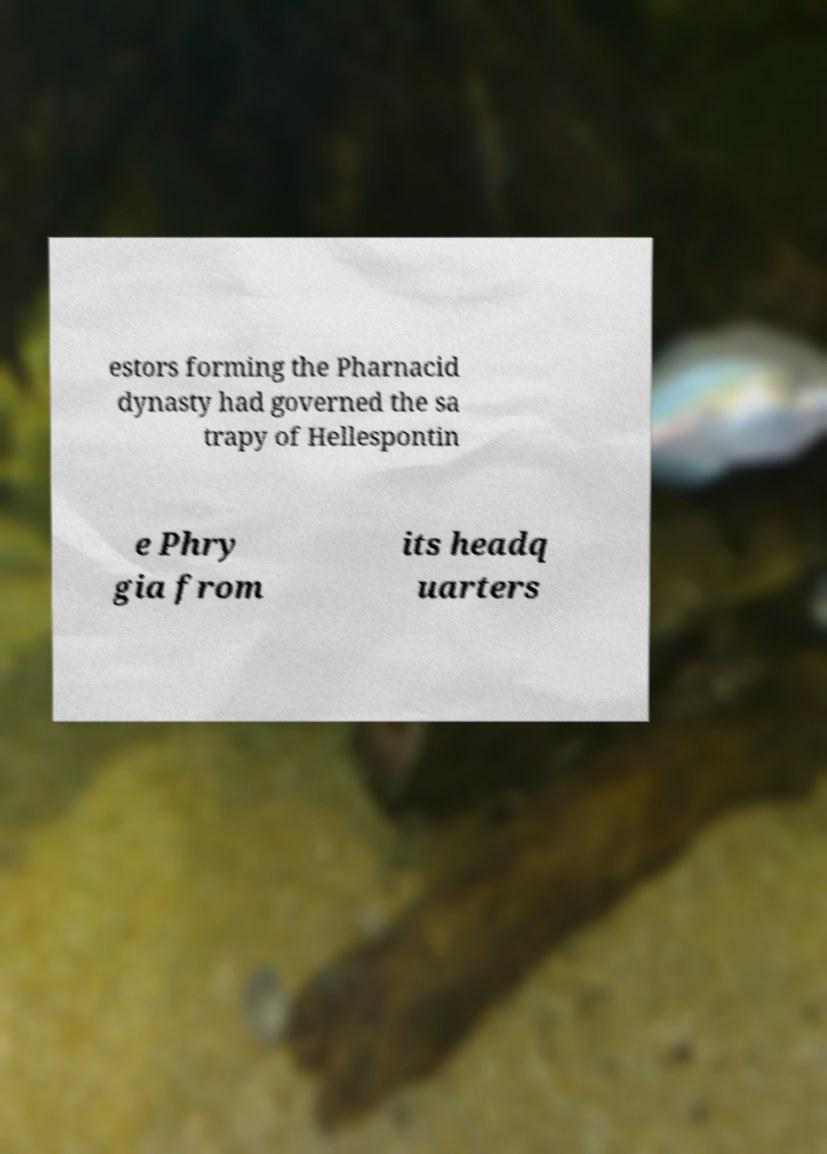What messages or text are displayed in this image? I need them in a readable, typed format. estors forming the Pharnacid dynasty had governed the sa trapy of Hellespontin e Phry gia from its headq uarters 